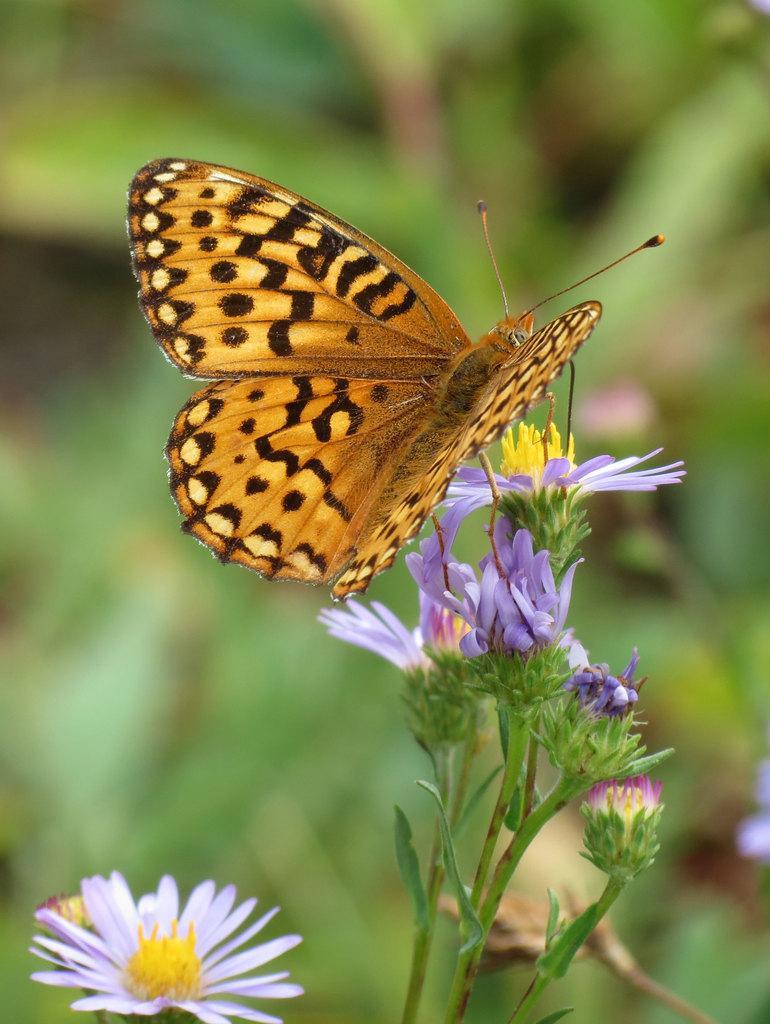Could you give a brief overview of what you see in this image? In this picture there is a butterfly standing on the plant and there are purple and pink color flowers on the plants. At the back the image is blurry. 